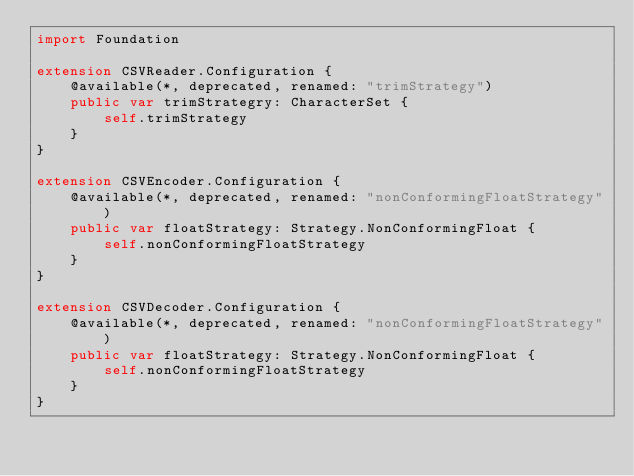Convert code to text. <code><loc_0><loc_0><loc_500><loc_500><_Swift_>import Foundation

extension CSVReader.Configuration {
    @available(*, deprecated, renamed: "trimStrategy")
    public var trimStrategry: CharacterSet {
        self.trimStrategy
    }
}

extension CSVEncoder.Configuration {
    @available(*, deprecated, renamed: "nonConformingFloatStrategy")
    public var floatStrategy: Strategy.NonConformingFloat {
        self.nonConformingFloatStrategy
    }
}

extension CSVDecoder.Configuration {
    @available(*, deprecated, renamed: "nonConformingFloatStrategy")
    public var floatStrategy: Strategy.NonConformingFloat {
        self.nonConformingFloatStrategy
    }
}
</code> 